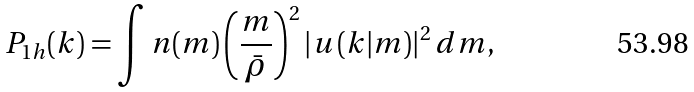Convert formula to latex. <formula><loc_0><loc_0><loc_500><loc_500>P _ { 1 h } ( k ) = \int n ( m ) \left ( \frac { m } { \bar { \rho } } \right ) ^ { 2 } \left | u \left ( k | m \right ) \right | ^ { 2 } d m ,</formula> 